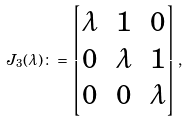Convert formula to latex. <formula><loc_0><loc_0><loc_500><loc_500>J _ { 3 } ( \lambda ) \colon = \begin{bmatrix} \lambda & 1 & 0 \\ 0 & \lambda & 1 \\ 0 & 0 & \lambda \end{bmatrix} ,</formula> 